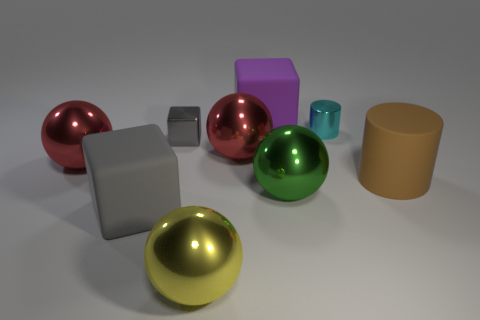What number of objects are big brown things or big purple matte blocks?
Make the answer very short. 2. What is the size of the gray thing behind the red ball left of the small shiny object in front of the cyan metal thing?
Offer a terse response. Small. What number of large metal balls have the same color as the big matte cylinder?
Your answer should be very brief. 0. How many things are the same material as the small gray cube?
Your response must be concise. 5. What number of objects are either gray things or shiny things that are on the right side of the big purple matte thing?
Your answer should be very brief. 4. What is the color of the tiny metal object on the right side of the large red sphere that is on the right side of the gray object in front of the tiny metal cube?
Offer a very short reply. Cyan. There is a matte thing in front of the brown rubber cylinder; what is its size?
Make the answer very short. Large. How many large things are cyan metallic cylinders or purple rubber spheres?
Provide a short and direct response. 0. There is a big rubber thing that is behind the gray rubber block and on the left side of the cyan cylinder; what color is it?
Offer a very short reply. Purple. Is there a yellow object of the same shape as the large green metallic object?
Give a very brief answer. Yes. 